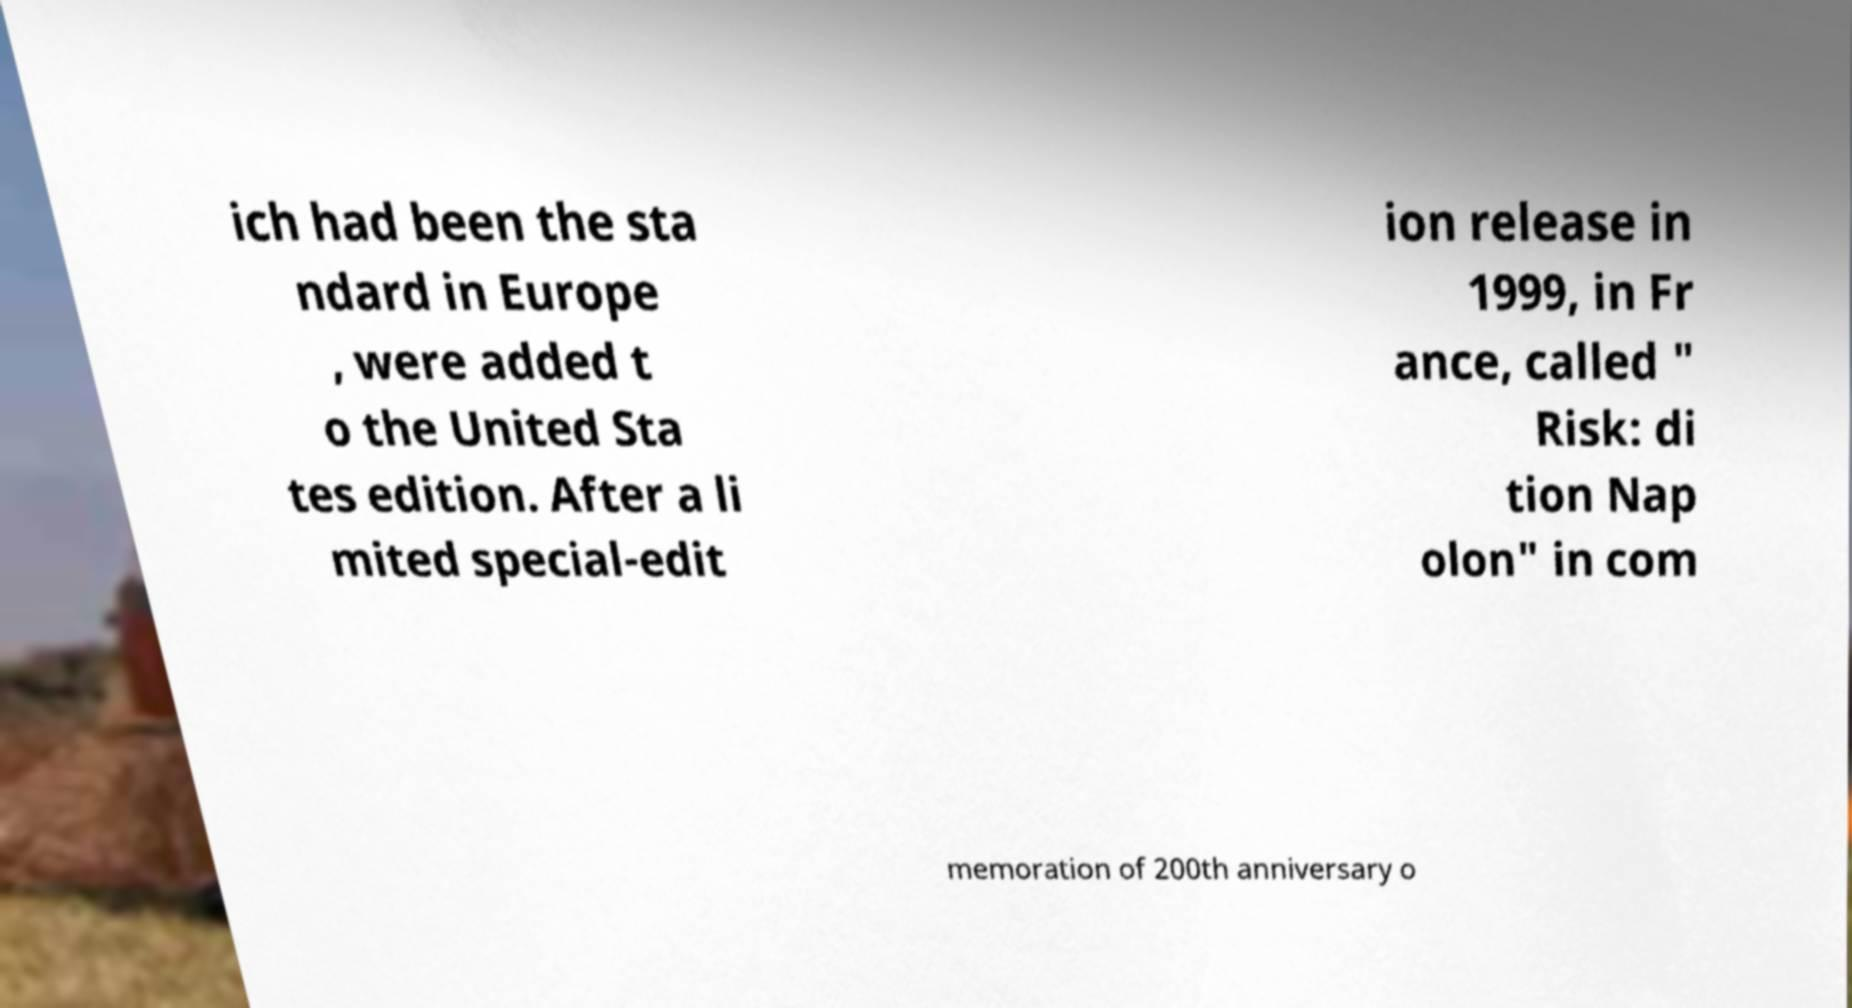Can you accurately transcribe the text from the provided image for me? ich had been the sta ndard in Europe , were added t o the United Sta tes edition. After a li mited special-edit ion release in 1999, in Fr ance, called " Risk: di tion Nap olon" in com memoration of 200th anniversary o 